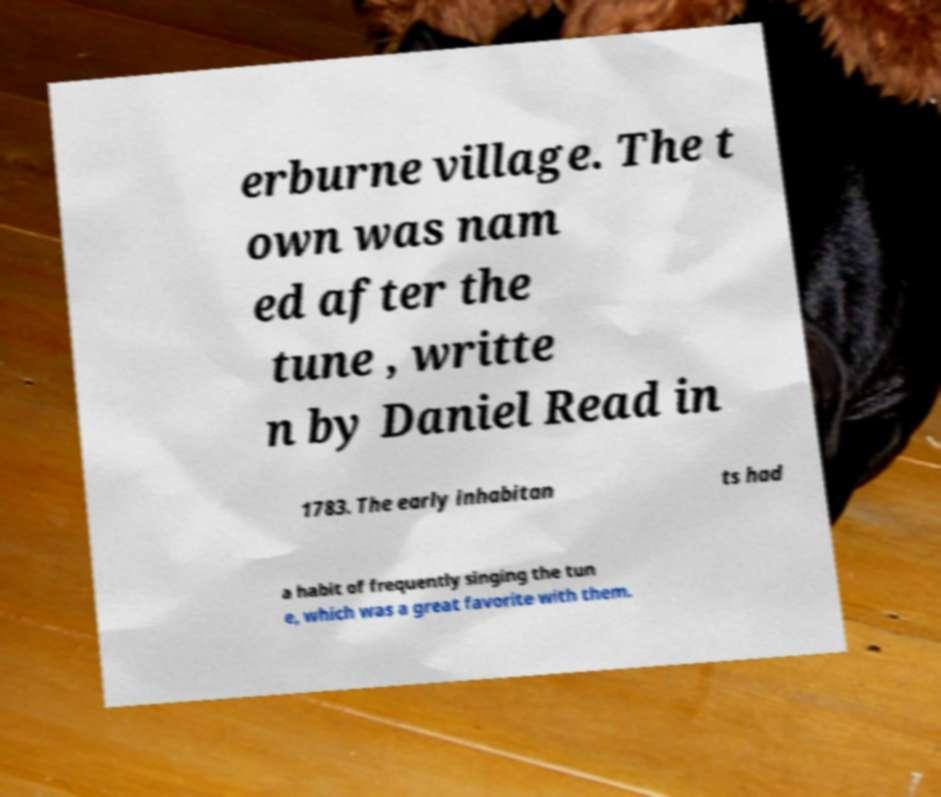I need the written content from this picture converted into text. Can you do that? erburne village. The t own was nam ed after the tune , writte n by Daniel Read in 1783. The early inhabitan ts had a habit of frequently singing the tun e, which was a great favorite with them. 